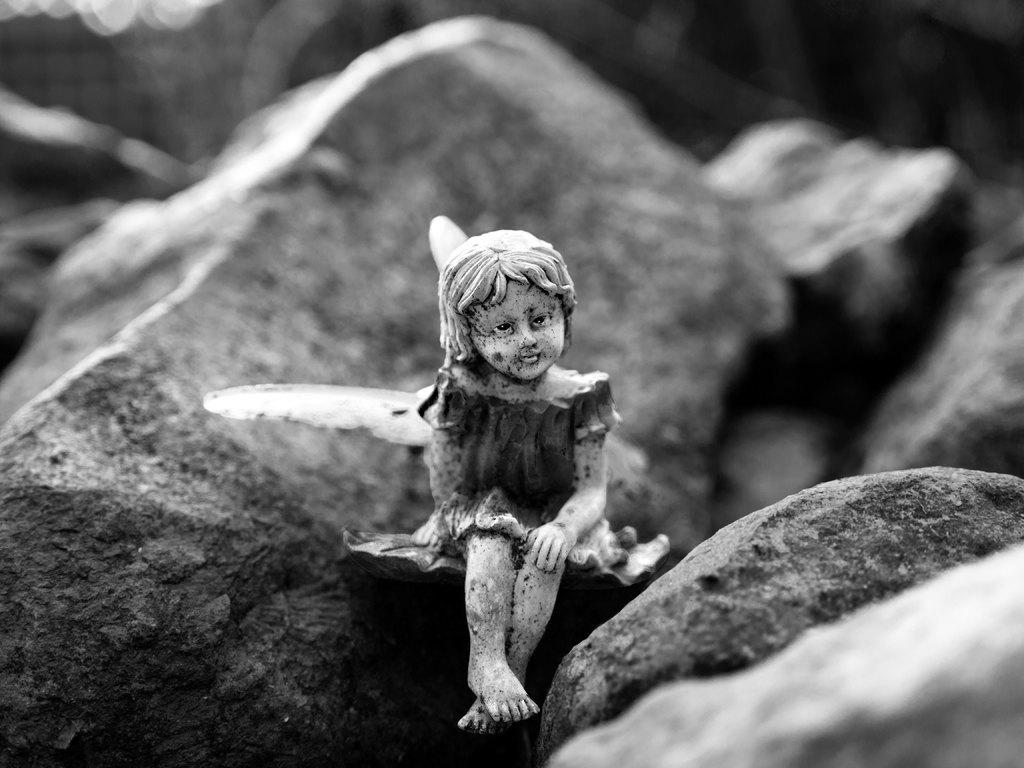What is the main subject of the image? There is a statue of a small girl in the image. What else can be seen in the image besides the statue? There are rocks visible in the image. Is the small girl in the image trying to swim through the rocks? There is no indication in the image that the small girl is swimming or that there is any water present for her to swim in. 